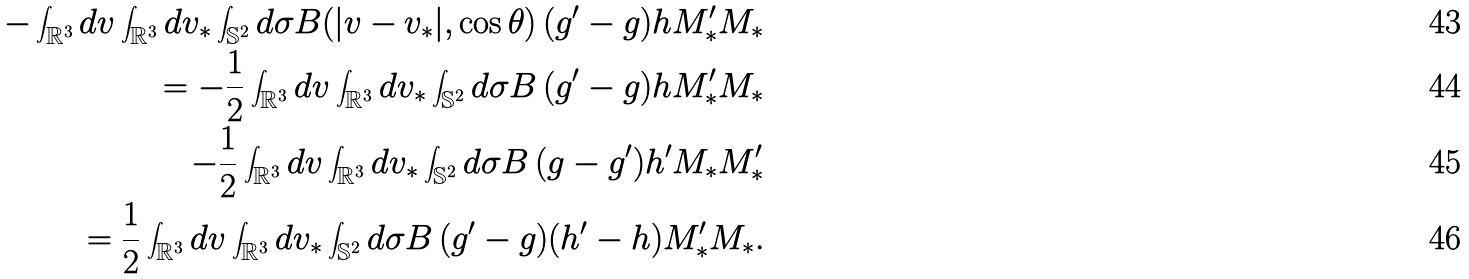<formula> <loc_0><loc_0><loc_500><loc_500>- \int _ { \mathbb { R } ^ { 3 } } d v \int _ { \mathbb { R } ^ { 3 } } d v _ { * } \int _ { \mathbb { S } ^ { 2 } } d \sigma B ( | v - v _ { * } | , \cos \theta ) \, ( g ^ { \prime } - g ) h M ^ { \prime } _ { * } M _ { * } \\ = - \frac { 1 } { 2 } \int _ { \mathbb { R } ^ { 3 } } d v \int _ { \mathbb { R } ^ { 3 } } d v _ { * } \int _ { \mathbb { S } ^ { 2 } } d \sigma B \, ( g ^ { \prime } - g ) h M ^ { \prime } _ { * } M _ { * } \\ - \frac { 1 } { 2 } \int _ { \mathbb { R } ^ { 3 } } d v \int _ { \mathbb { R } ^ { 3 } } d v _ { * } \int _ { \mathbb { S } ^ { 2 } } d \sigma B \, ( g - g ^ { \prime } ) h ^ { \prime } M _ { * } M ^ { \prime } _ { * } \\ = \frac { 1 } { 2 } \int _ { \mathbb { R } ^ { 3 } } d v \int _ { \mathbb { R } ^ { 3 } } d v _ { * } \int _ { \mathbb { S } ^ { 2 } } d \sigma B \, ( g ^ { \prime } - g ) ( h ^ { \prime } - h ) M ^ { \prime } _ { * } M _ { * } .</formula> 